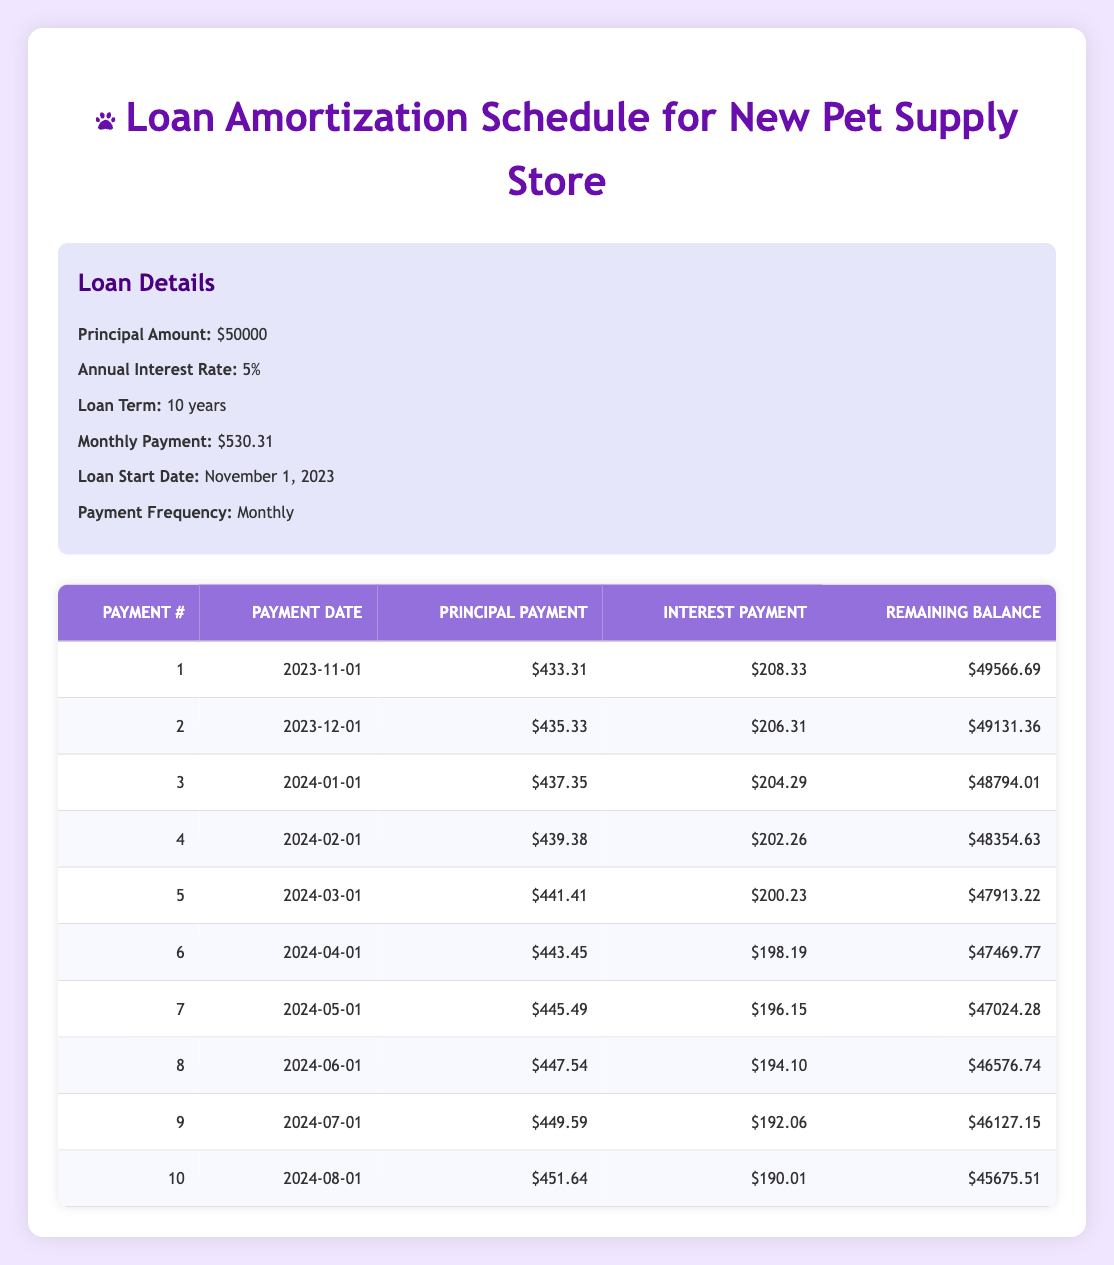What is the total principal payment made in the first three months? The principal payments for the first three months are 433.31, 435.33, and 437.35. Adding these gives: 433.31 + 435.33 + 437.35 = 1306.99.
Answer: 1306.99 What is the remaining balance after the 5th payment? Looking at the 5th payment row, the remaining balance is listed as 47913.22.
Answer: 47913.22 Is the interest payment in the second month higher than in the first month? The interest payment for the first month is 208.33, and for the second month, it is 206.31. Since 206.31 is less than 208.33, the statement is false.
Answer: No What is the average monthly principal payment for the first ten payments? The principal payments for the first ten payments are: 433.31, 435.33, 437.35, 439.38, 441.41, 443.45, 445.49, 447.54, 449.59, and 451.64. Adding these values gives a total of 4393.69. To find the average, divide by the number of payments: 4393.69 / 10 = 439.37.
Answer: 439.37 What is the total amount paid in interest for the first six months? The interest payments for the first six months are: 208.33, 206.31, 204.29, 202.26, 200.23, and 198.19. Adding these gives: 208.33 + 206.31 + 204.29 + 202.26 + 200.23 + 198.19 = 1219.61.
Answer: 1219.61 What is the difference between the principal payment in the 1st and the 10th month? The principal payment in the 1st month is 433.31 and in the 10th month is 451.64. To get the difference: 451.64 - 433.31 = 18.33.
Answer: 18.33 Are the remaining balances after the 4th payment and the 5th payment equal? The remaining balance after the 4th payment is 48354.63, and after the 5th payment is 47913.22. Since these balances are not equal, the answer is no.
Answer: No How much did the interest payment decrease from the first month to the sixth month? The interest payment in the first month is 208.33, and in the sixth month, it is 198.19. The decrease is: 208.33 - 198.19 = 10.14.
Answer: 10.14 What is the remaining balance after the 3rd payment? From the amortization schedule, the remaining balance after the 3rd payment is 48794.01.
Answer: 48794.01 